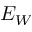Convert formula to latex. <formula><loc_0><loc_0><loc_500><loc_500>E _ { W }</formula> 